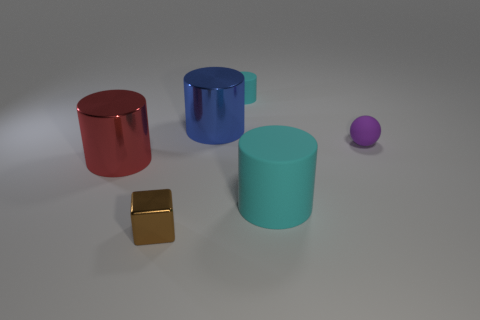There is a shiny object to the left of the small brown cube; does it have the same size as the cyan cylinder in front of the tiny cyan thing?
Your answer should be compact. Yes. Are there fewer big blue metal cylinders than objects?
Your answer should be compact. Yes. How many matte objects are red cylinders or large yellow spheres?
Your answer should be compact. 0. There is a tiny brown metallic thing that is in front of the tiny purple sphere; are there any rubber cylinders in front of it?
Your answer should be compact. No. Does the cylinder behind the big blue object have the same material as the purple thing?
Your answer should be very brief. Yes. How many other things are there of the same color as the large matte cylinder?
Make the answer very short. 1. Is the small shiny cube the same color as the matte sphere?
Your answer should be compact. No. How big is the cyan matte object that is behind the cylinder that is on the left side of the tiny brown cube?
Your response must be concise. Small. Are the cyan cylinder behind the rubber sphere and the cylinder that is right of the small cyan matte thing made of the same material?
Your answer should be compact. Yes. Do the tiny rubber object left of the small purple rubber sphere and the large rubber cylinder have the same color?
Provide a short and direct response. Yes. 